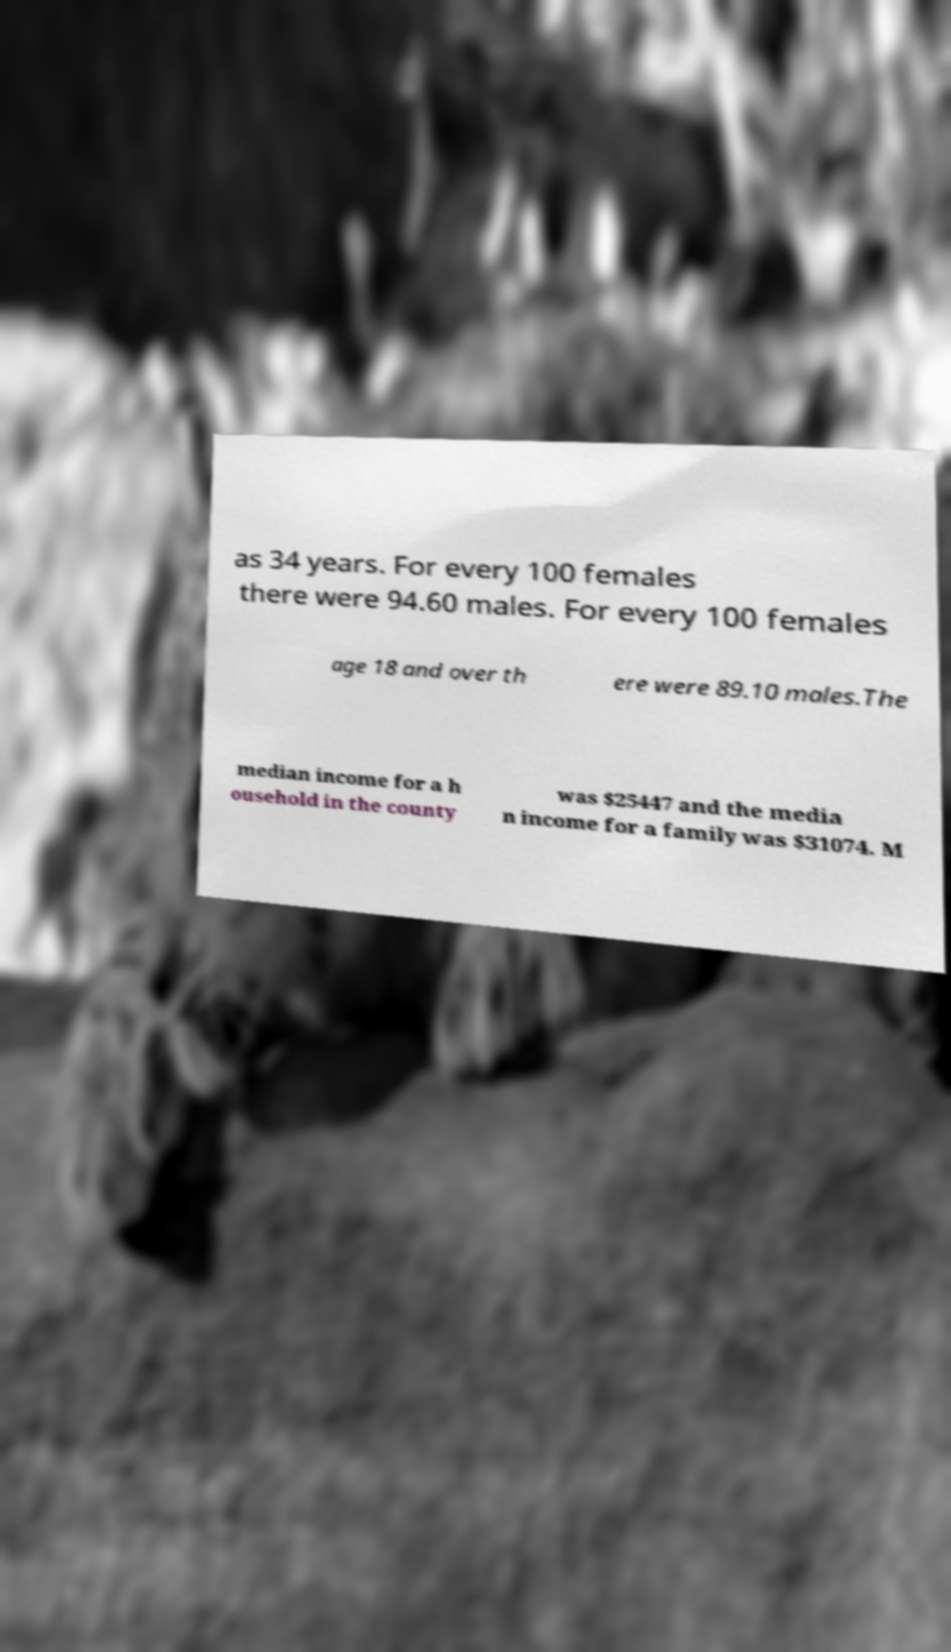For documentation purposes, I need the text within this image transcribed. Could you provide that? as 34 years. For every 100 females there were 94.60 males. For every 100 females age 18 and over th ere were 89.10 males.The median income for a h ousehold in the county was $25447 and the media n income for a family was $31074. M 